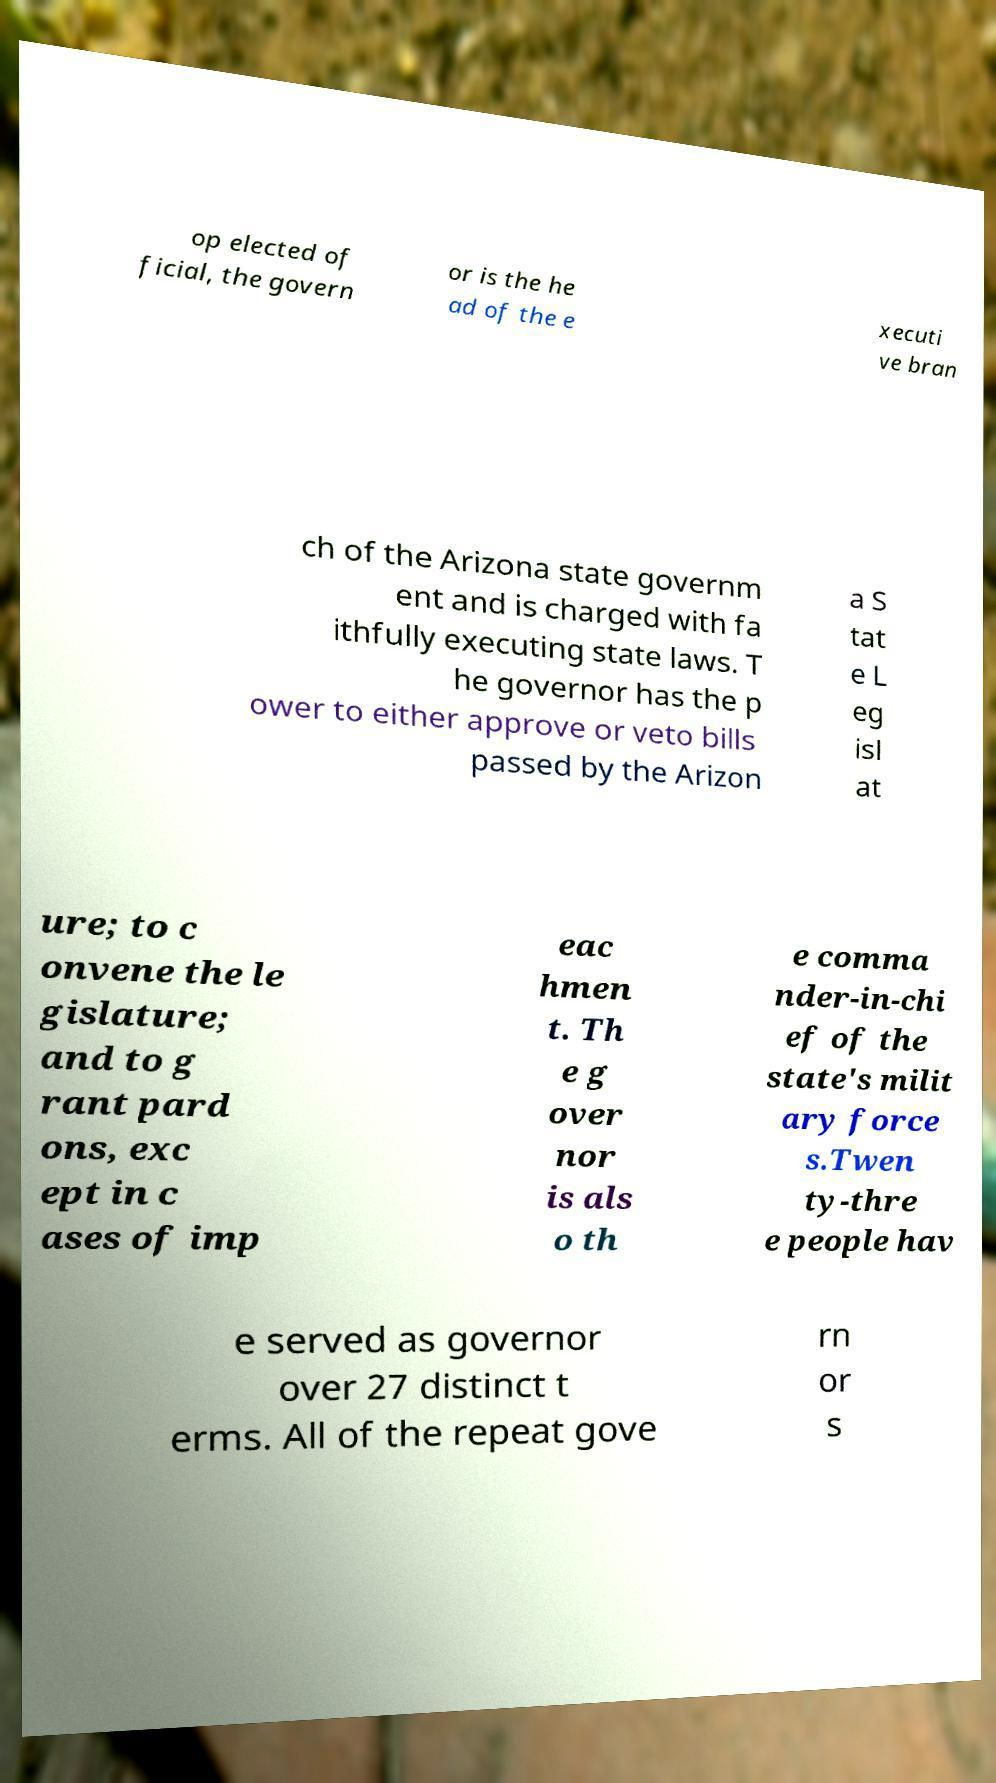Could you assist in decoding the text presented in this image and type it out clearly? op elected of ficial, the govern or is the he ad of the e xecuti ve bran ch of the Arizona state governm ent and is charged with fa ithfully executing state laws. T he governor has the p ower to either approve or veto bills passed by the Arizon a S tat e L eg isl at ure; to c onvene the le gislature; and to g rant pard ons, exc ept in c ases of imp eac hmen t. Th e g over nor is als o th e comma nder-in-chi ef of the state's milit ary force s.Twen ty-thre e people hav e served as governor over 27 distinct t erms. All of the repeat gove rn or s 